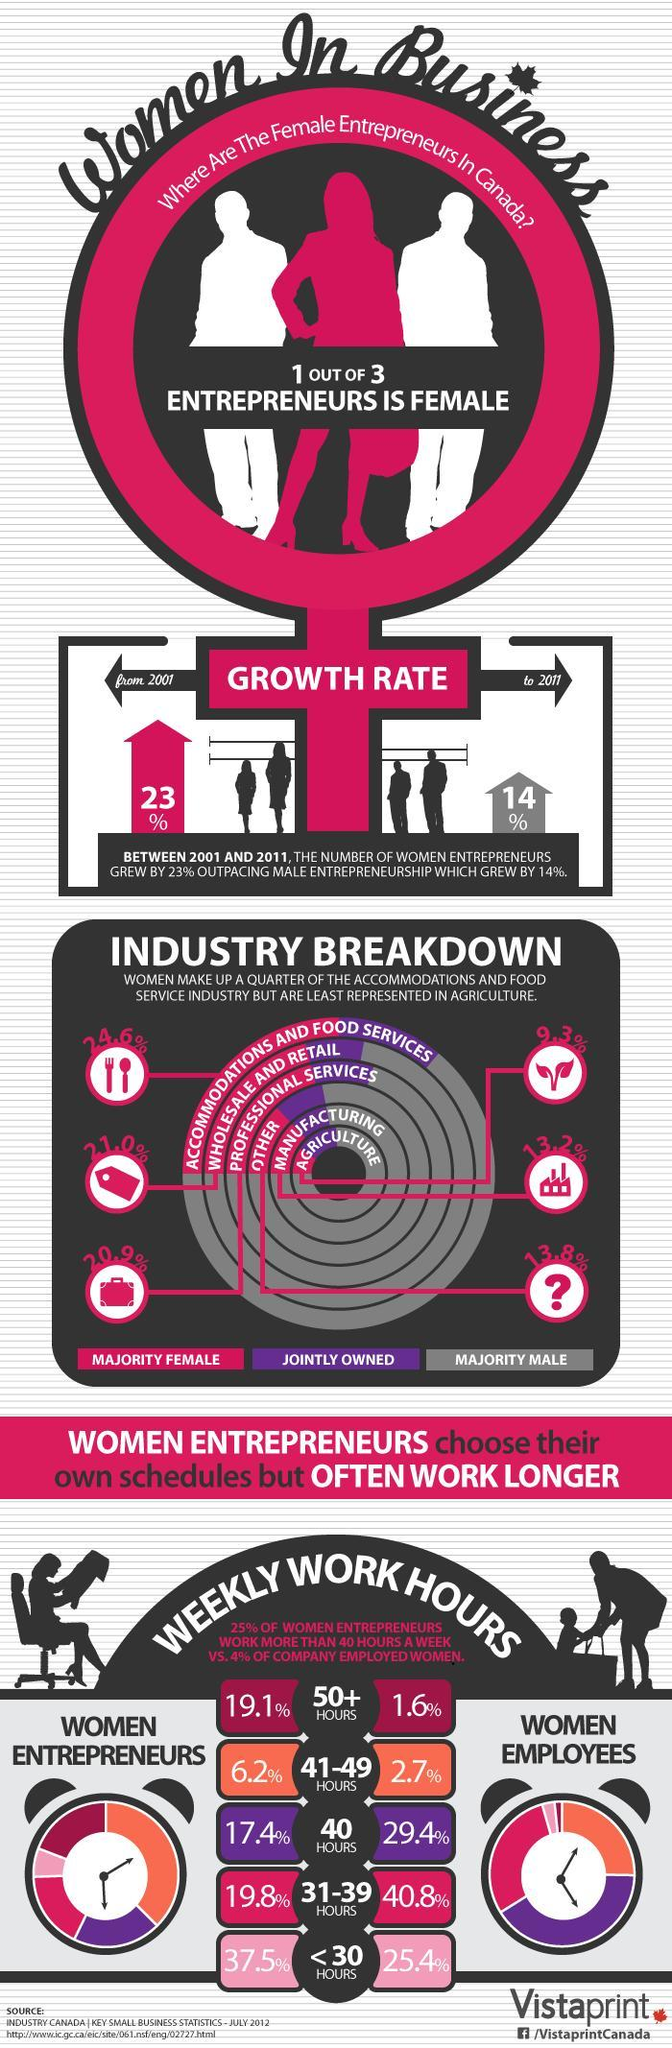What is the majority percentage of females in the manufacturing industry of Canada?
Answer the question with a short phrase. 13.2% What percent of the women entrepreneurs in Canada work for less than 30 hours a week? 37.5% What percent of the women entrepreneurs in Canada work for 31-39 hours a week? 19.8% What is the majority percentage of females in the wholesale & retail industry of Canada? 21.0% What percent of the women employees in Canada work for more than 50 hours a week? 1.6% What percent of the women employees in Canada work for 41-49 hours a week? 2.7% How many hours per week is spend on work by 17.4% of the women entrepreneurs in Canada? 40 HOURS 